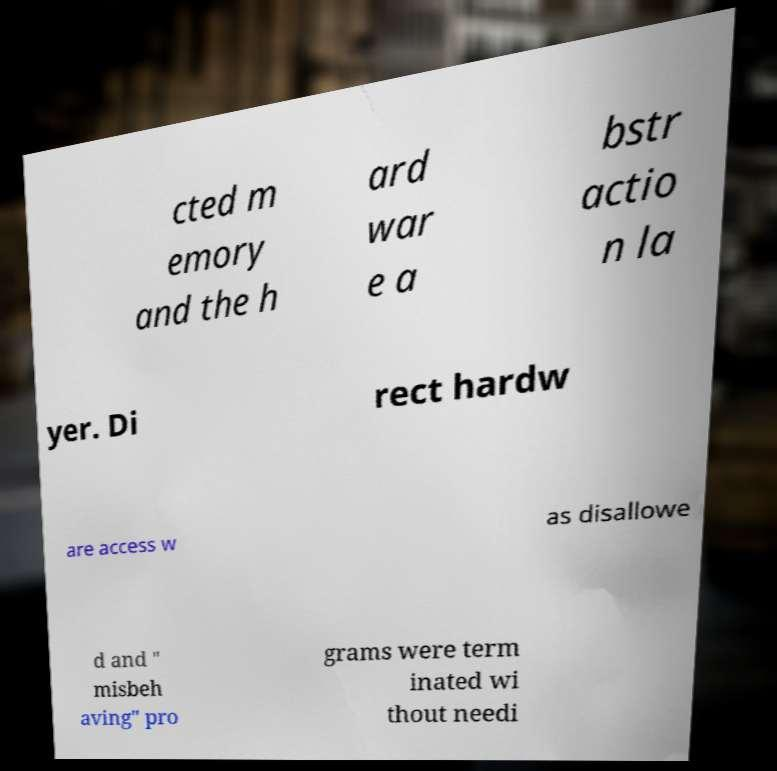Please identify and transcribe the text found in this image. cted m emory and the h ard war e a bstr actio n la yer. Di rect hardw are access w as disallowe d and " misbeh aving" pro grams were term inated wi thout needi 